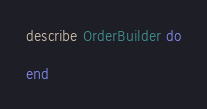<code> <loc_0><loc_0><loc_500><loc_500><_Ruby_>describe OrderBuilder do
  
end
</code> 